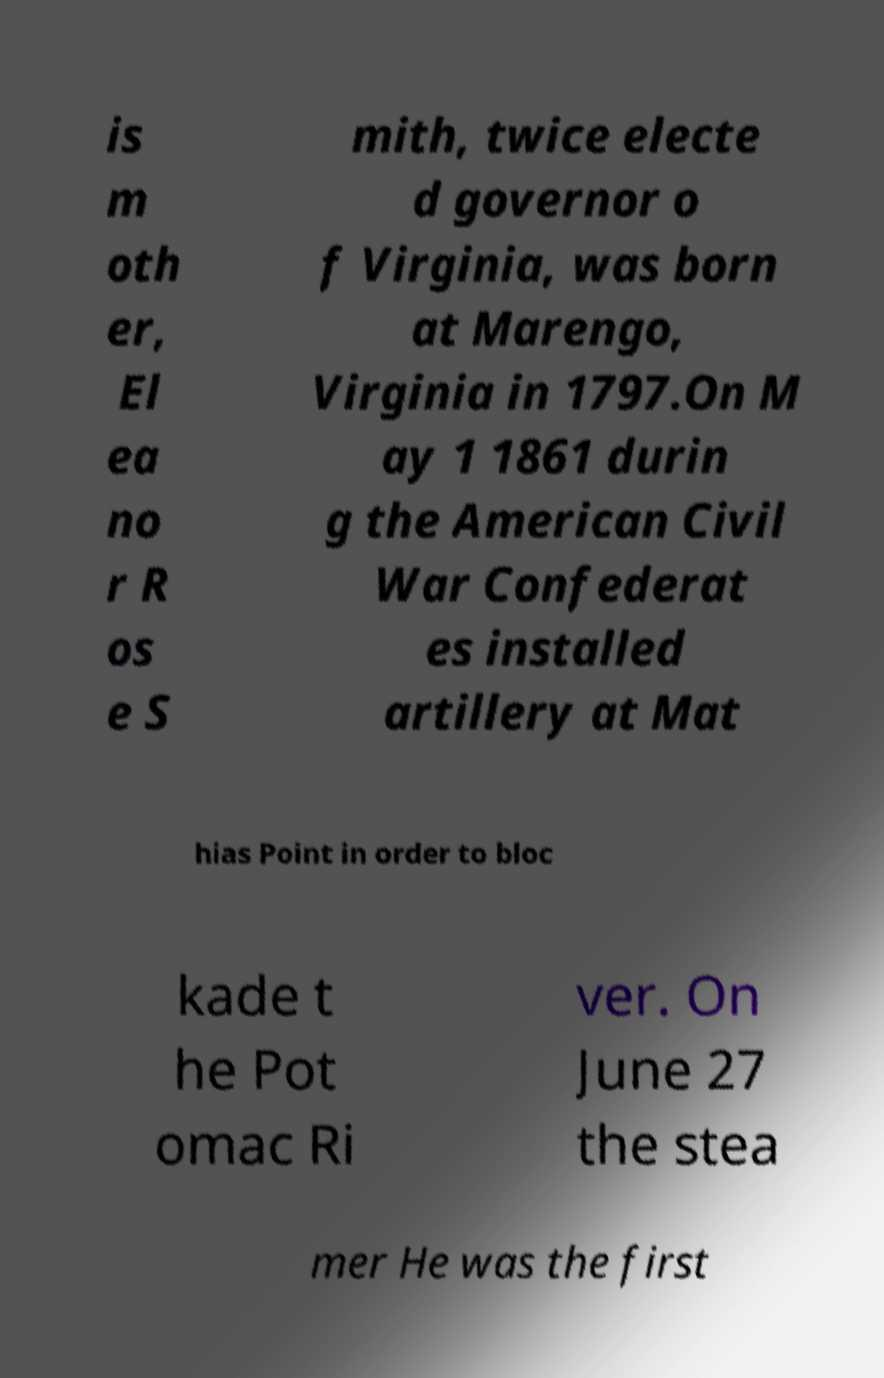Could you extract and type out the text from this image? is m oth er, El ea no r R os e S mith, twice electe d governor o f Virginia, was born at Marengo, Virginia in 1797.On M ay 1 1861 durin g the American Civil War Confederat es installed artillery at Mat hias Point in order to bloc kade t he Pot omac Ri ver. On June 27 the stea mer He was the first 